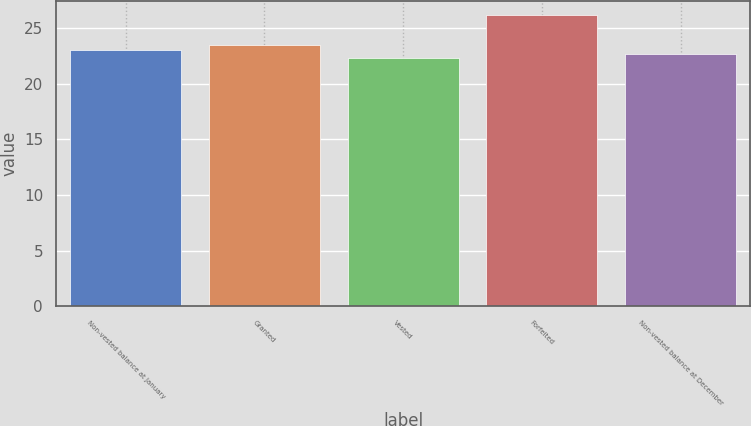<chart> <loc_0><loc_0><loc_500><loc_500><bar_chart><fcel>Non-vested balance at January<fcel>Granted<fcel>Vested<fcel>Forfeited<fcel>Non-vested balance at December<nl><fcel>23.03<fcel>23.42<fcel>22.25<fcel>26.12<fcel>22.64<nl></chart> 